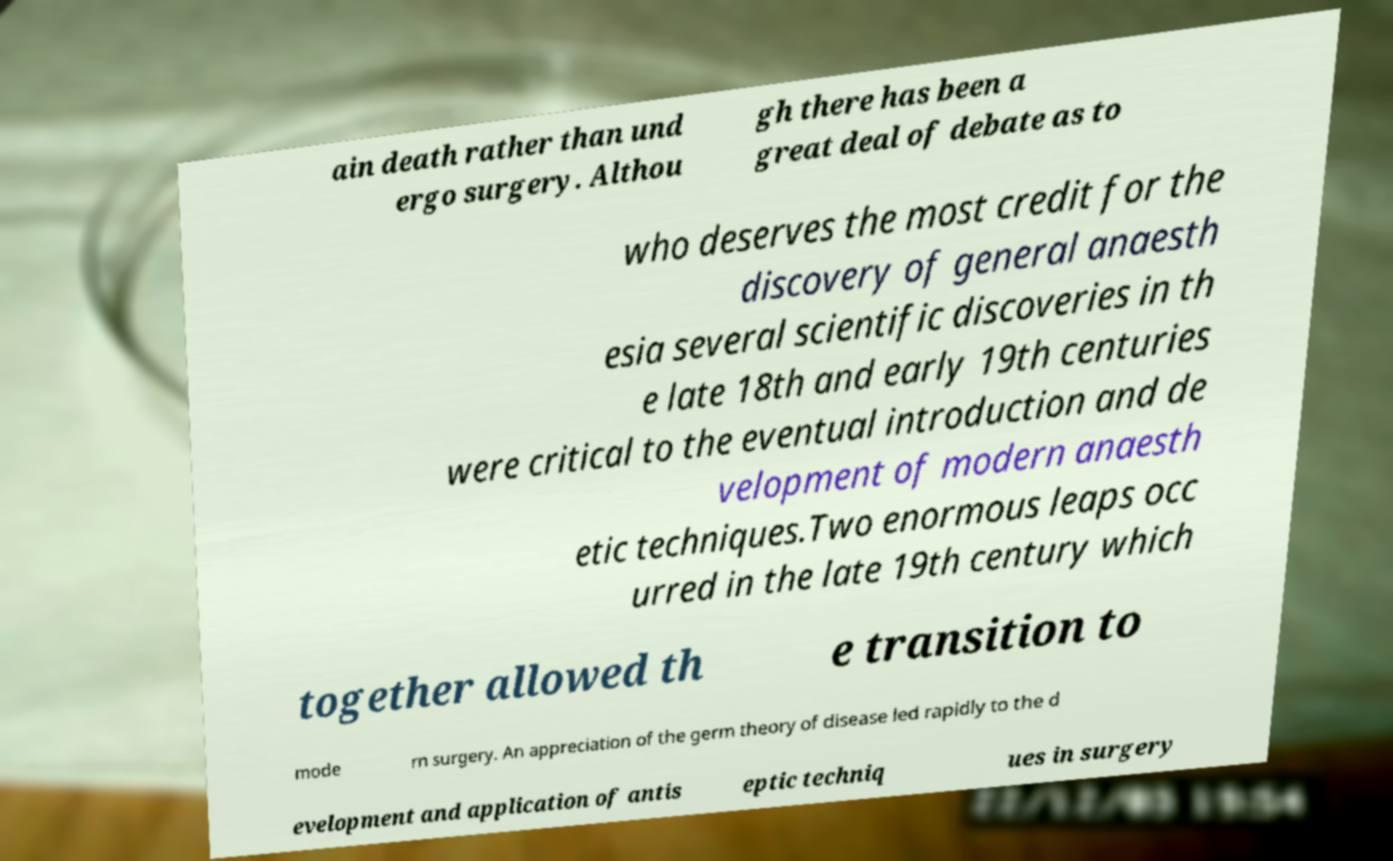I need the written content from this picture converted into text. Can you do that? ain death rather than und ergo surgery. Althou gh there has been a great deal of debate as to who deserves the most credit for the discovery of general anaesth esia several scientific discoveries in th e late 18th and early 19th centuries were critical to the eventual introduction and de velopment of modern anaesth etic techniques.Two enormous leaps occ urred in the late 19th century which together allowed th e transition to mode rn surgery. An appreciation of the germ theory of disease led rapidly to the d evelopment and application of antis eptic techniq ues in surgery 